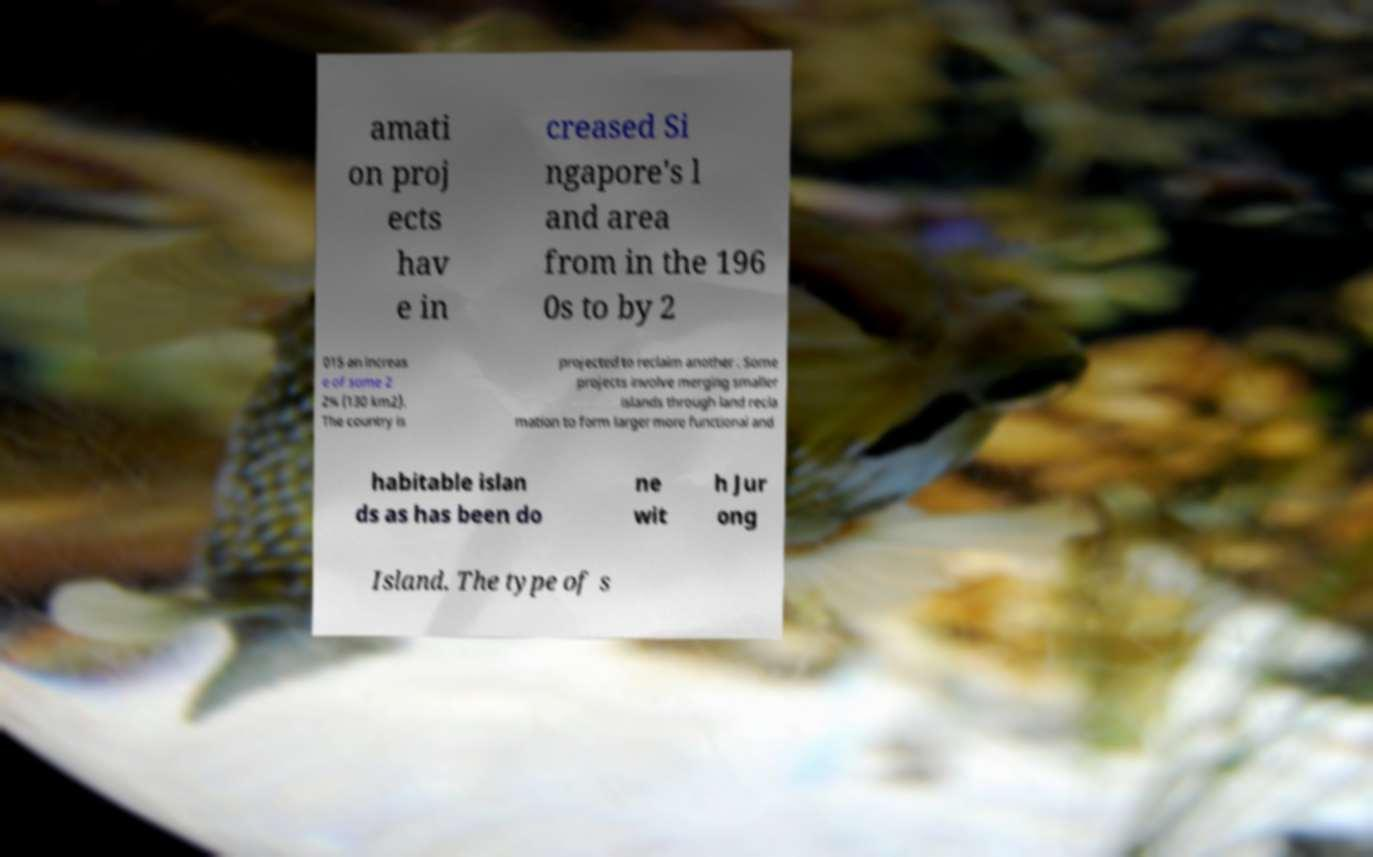Can you accurately transcribe the text from the provided image for me? amati on proj ects hav e in creased Si ngapore's l and area from in the 196 0s to by 2 015 an increas e of some 2 2% (130 km2). The country is projected to reclaim another . Some projects involve merging smaller islands through land recla mation to form larger more functional and habitable islan ds as has been do ne wit h Jur ong Island. The type of s 